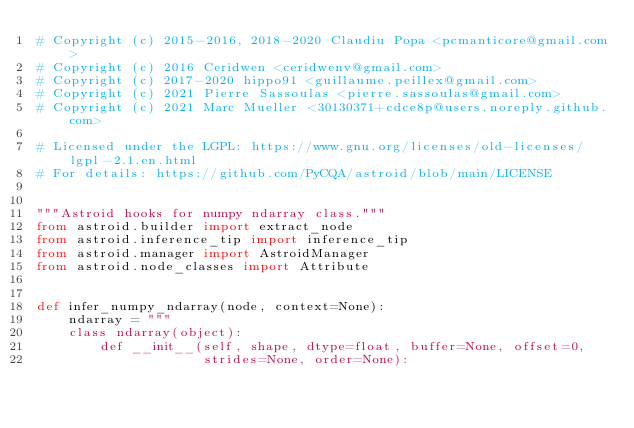Convert code to text. <code><loc_0><loc_0><loc_500><loc_500><_Python_># Copyright (c) 2015-2016, 2018-2020 Claudiu Popa <pcmanticore@gmail.com>
# Copyright (c) 2016 Ceridwen <ceridwenv@gmail.com>
# Copyright (c) 2017-2020 hippo91 <guillaume.peillex@gmail.com>
# Copyright (c) 2021 Pierre Sassoulas <pierre.sassoulas@gmail.com>
# Copyright (c) 2021 Marc Mueller <30130371+cdce8p@users.noreply.github.com>

# Licensed under the LGPL: https://www.gnu.org/licenses/old-licenses/lgpl-2.1.en.html
# For details: https://github.com/PyCQA/astroid/blob/main/LICENSE


"""Astroid hooks for numpy ndarray class."""
from astroid.builder import extract_node
from astroid.inference_tip import inference_tip
from astroid.manager import AstroidManager
from astroid.node_classes import Attribute


def infer_numpy_ndarray(node, context=None):
    ndarray = """
    class ndarray(object):
        def __init__(self, shape, dtype=float, buffer=None, offset=0,
                     strides=None, order=None):</code> 